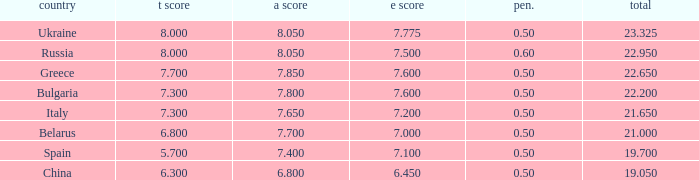Help me parse the entirety of this table. {'header': ['country', 't score', 'a score', 'e score', 'pen.', 'total'], 'rows': [['Ukraine', '8.000', '8.050', '7.775', '0.50', '23.325'], ['Russia', '8.000', '8.050', '7.500', '0.60', '22.950'], ['Greece', '7.700', '7.850', '7.600', '0.50', '22.650'], ['Bulgaria', '7.300', '7.800', '7.600', '0.50', '22.200'], ['Italy', '7.300', '7.650', '7.200', '0.50', '21.650'], ['Belarus', '6.800', '7.700', '7.000', '0.50', '21.000'], ['Spain', '5.700', '7.400', '7.100', '0.50', '19.700'], ['China', '6.300', '6.800', '6.450', '0.50', '19.050']]} What's the sum of A Score that also has a score lower than 7.3 and an E Score larger than 7.1? None. 